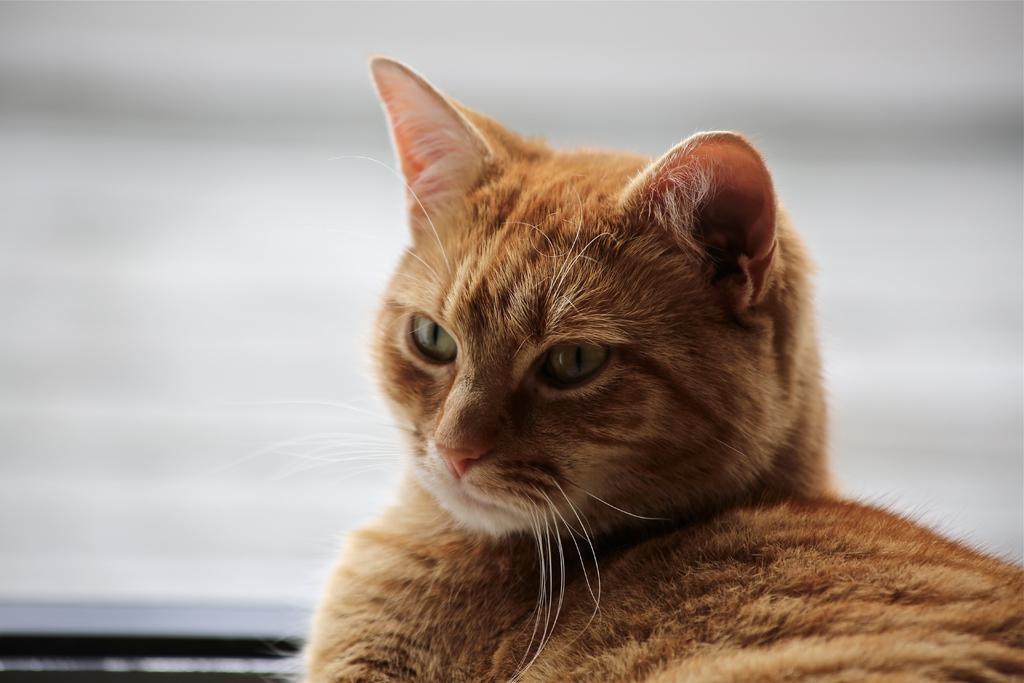How would you summarize this image in a sentence or two? In this picture we can see a cat. 